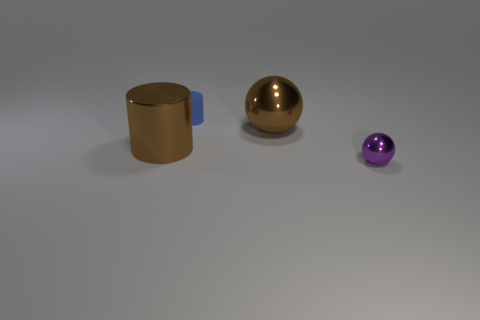Add 1 brown cylinders. How many objects exist? 5 Add 2 large things. How many large things exist? 4 Subtract 0 gray spheres. How many objects are left? 4 Subtract all tiny metal balls. Subtract all cyan rubber things. How many objects are left? 3 Add 3 brown metal cylinders. How many brown metal cylinders are left? 4 